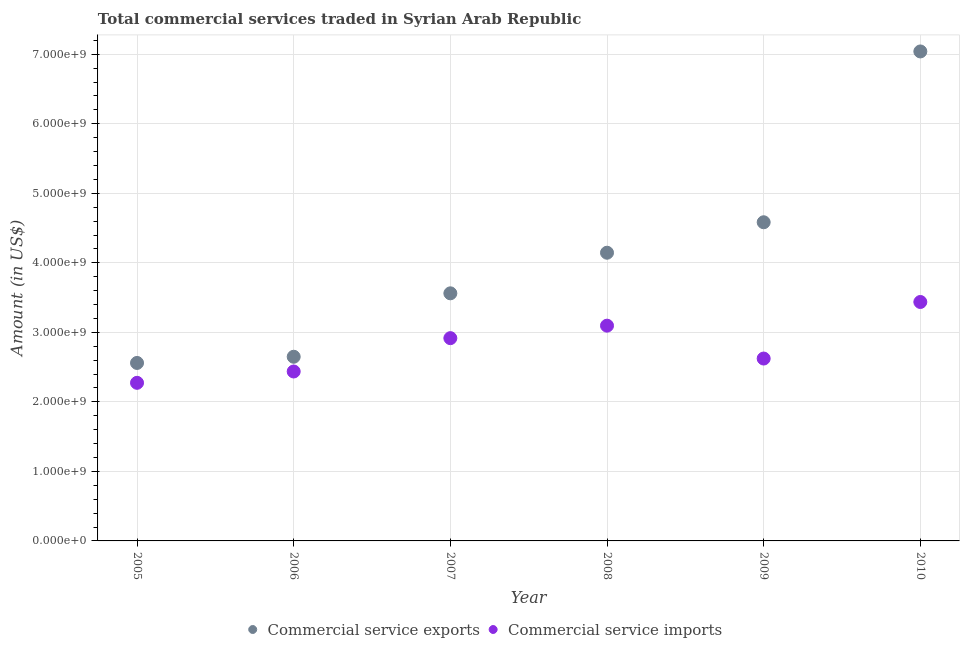Is the number of dotlines equal to the number of legend labels?
Ensure brevity in your answer.  Yes. What is the amount of commercial service imports in 2007?
Your answer should be compact. 2.92e+09. Across all years, what is the maximum amount of commercial service exports?
Your answer should be very brief. 7.04e+09. Across all years, what is the minimum amount of commercial service imports?
Provide a short and direct response. 2.27e+09. In which year was the amount of commercial service exports maximum?
Your answer should be very brief. 2010. What is the total amount of commercial service exports in the graph?
Your answer should be very brief. 2.45e+1. What is the difference between the amount of commercial service imports in 2005 and that in 2008?
Give a very brief answer. -8.22e+08. What is the difference between the amount of commercial service imports in 2010 and the amount of commercial service exports in 2005?
Offer a very short reply. 8.77e+08. What is the average amount of commercial service imports per year?
Give a very brief answer. 2.80e+09. In the year 2008, what is the difference between the amount of commercial service exports and amount of commercial service imports?
Your answer should be very brief. 1.05e+09. In how many years, is the amount of commercial service imports greater than 4800000000 US$?
Give a very brief answer. 0. What is the ratio of the amount of commercial service exports in 2007 to that in 2010?
Your answer should be very brief. 0.51. Is the difference between the amount of commercial service exports in 2008 and 2010 greater than the difference between the amount of commercial service imports in 2008 and 2010?
Keep it short and to the point. No. What is the difference between the highest and the second highest amount of commercial service exports?
Provide a succinct answer. 2.46e+09. What is the difference between the highest and the lowest amount of commercial service exports?
Provide a short and direct response. 4.48e+09. In how many years, is the amount of commercial service imports greater than the average amount of commercial service imports taken over all years?
Your response must be concise. 3. Does the amount of commercial service exports monotonically increase over the years?
Provide a succinct answer. Yes. Is the amount of commercial service imports strictly greater than the amount of commercial service exports over the years?
Offer a terse response. No. Is the amount of commercial service exports strictly less than the amount of commercial service imports over the years?
Ensure brevity in your answer.  No. Does the graph contain any zero values?
Provide a succinct answer. No. How are the legend labels stacked?
Your response must be concise. Horizontal. What is the title of the graph?
Your answer should be compact. Total commercial services traded in Syrian Arab Republic. Does "GDP per capita" appear as one of the legend labels in the graph?
Offer a very short reply. No. What is the Amount (in US$) in Commercial service exports in 2005?
Keep it short and to the point. 2.56e+09. What is the Amount (in US$) of Commercial service imports in 2005?
Your response must be concise. 2.27e+09. What is the Amount (in US$) in Commercial service exports in 2006?
Provide a succinct answer. 2.65e+09. What is the Amount (in US$) of Commercial service imports in 2006?
Ensure brevity in your answer.  2.44e+09. What is the Amount (in US$) in Commercial service exports in 2007?
Keep it short and to the point. 3.56e+09. What is the Amount (in US$) of Commercial service imports in 2007?
Offer a terse response. 2.92e+09. What is the Amount (in US$) in Commercial service exports in 2008?
Give a very brief answer. 4.15e+09. What is the Amount (in US$) of Commercial service imports in 2008?
Give a very brief answer. 3.10e+09. What is the Amount (in US$) in Commercial service exports in 2009?
Offer a very short reply. 4.58e+09. What is the Amount (in US$) in Commercial service imports in 2009?
Give a very brief answer. 2.62e+09. What is the Amount (in US$) in Commercial service exports in 2010?
Your response must be concise. 7.04e+09. What is the Amount (in US$) in Commercial service imports in 2010?
Your answer should be compact. 3.44e+09. Across all years, what is the maximum Amount (in US$) of Commercial service exports?
Give a very brief answer. 7.04e+09. Across all years, what is the maximum Amount (in US$) in Commercial service imports?
Offer a terse response. 3.44e+09. Across all years, what is the minimum Amount (in US$) of Commercial service exports?
Give a very brief answer. 2.56e+09. Across all years, what is the minimum Amount (in US$) in Commercial service imports?
Your answer should be very brief. 2.27e+09. What is the total Amount (in US$) in Commercial service exports in the graph?
Your answer should be very brief. 2.45e+1. What is the total Amount (in US$) in Commercial service imports in the graph?
Provide a succinct answer. 1.68e+1. What is the difference between the Amount (in US$) in Commercial service exports in 2005 and that in 2006?
Give a very brief answer. -8.90e+07. What is the difference between the Amount (in US$) in Commercial service imports in 2005 and that in 2006?
Your answer should be compact. -1.63e+08. What is the difference between the Amount (in US$) in Commercial service exports in 2005 and that in 2007?
Keep it short and to the point. -1.00e+09. What is the difference between the Amount (in US$) in Commercial service imports in 2005 and that in 2007?
Keep it short and to the point. -6.43e+08. What is the difference between the Amount (in US$) of Commercial service exports in 2005 and that in 2008?
Offer a terse response. -1.59e+09. What is the difference between the Amount (in US$) of Commercial service imports in 2005 and that in 2008?
Ensure brevity in your answer.  -8.22e+08. What is the difference between the Amount (in US$) in Commercial service exports in 2005 and that in 2009?
Ensure brevity in your answer.  -2.02e+09. What is the difference between the Amount (in US$) in Commercial service imports in 2005 and that in 2009?
Provide a succinct answer. -3.49e+08. What is the difference between the Amount (in US$) in Commercial service exports in 2005 and that in 2010?
Give a very brief answer. -4.48e+09. What is the difference between the Amount (in US$) of Commercial service imports in 2005 and that in 2010?
Give a very brief answer. -1.16e+09. What is the difference between the Amount (in US$) of Commercial service exports in 2006 and that in 2007?
Your answer should be very brief. -9.12e+08. What is the difference between the Amount (in US$) in Commercial service imports in 2006 and that in 2007?
Give a very brief answer. -4.80e+08. What is the difference between the Amount (in US$) of Commercial service exports in 2006 and that in 2008?
Your response must be concise. -1.50e+09. What is the difference between the Amount (in US$) in Commercial service imports in 2006 and that in 2008?
Your response must be concise. -6.59e+08. What is the difference between the Amount (in US$) of Commercial service exports in 2006 and that in 2009?
Offer a terse response. -1.93e+09. What is the difference between the Amount (in US$) of Commercial service imports in 2006 and that in 2009?
Your answer should be very brief. -1.86e+08. What is the difference between the Amount (in US$) in Commercial service exports in 2006 and that in 2010?
Your answer should be compact. -4.39e+09. What is the difference between the Amount (in US$) of Commercial service imports in 2006 and that in 2010?
Provide a short and direct response. -1.00e+09. What is the difference between the Amount (in US$) in Commercial service exports in 2007 and that in 2008?
Your answer should be compact. -5.84e+08. What is the difference between the Amount (in US$) of Commercial service imports in 2007 and that in 2008?
Ensure brevity in your answer.  -1.80e+08. What is the difference between the Amount (in US$) of Commercial service exports in 2007 and that in 2009?
Ensure brevity in your answer.  -1.02e+09. What is the difference between the Amount (in US$) of Commercial service imports in 2007 and that in 2009?
Give a very brief answer. 2.93e+08. What is the difference between the Amount (in US$) in Commercial service exports in 2007 and that in 2010?
Keep it short and to the point. -3.48e+09. What is the difference between the Amount (in US$) in Commercial service imports in 2007 and that in 2010?
Your answer should be very brief. -5.20e+08. What is the difference between the Amount (in US$) in Commercial service exports in 2008 and that in 2009?
Make the answer very short. -4.38e+08. What is the difference between the Amount (in US$) of Commercial service imports in 2008 and that in 2009?
Offer a terse response. 4.73e+08. What is the difference between the Amount (in US$) of Commercial service exports in 2008 and that in 2010?
Your answer should be very brief. -2.90e+09. What is the difference between the Amount (in US$) in Commercial service imports in 2008 and that in 2010?
Give a very brief answer. -3.41e+08. What is the difference between the Amount (in US$) of Commercial service exports in 2009 and that in 2010?
Offer a terse response. -2.46e+09. What is the difference between the Amount (in US$) in Commercial service imports in 2009 and that in 2010?
Provide a short and direct response. -8.14e+08. What is the difference between the Amount (in US$) of Commercial service exports in 2005 and the Amount (in US$) of Commercial service imports in 2006?
Ensure brevity in your answer.  1.23e+08. What is the difference between the Amount (in US$) of Commercial service exports in 2005 and the Amount (in US$) of Commercial service imports in 2007?
Offer a terse response. -3.57e+08. What is the difference between the Amount (in US$) in Commercial service exports in 2005 and the Amount (in US$) in Commercial service imports in 2008?
Give a very brief answer. -5.36e+08. What is the difference between the Amount (in US$) of Commercial service exports in 2005 and the Amount (in US$) of Commercial service imports in 2009?
Your answer should be very brief. -6.32e+07. What is the difference between the Amount (in US$) of Commercial service exports in 2005 and the Amount (in US$) of Commercial service imports in 2010?
Your response must be concise. -8.77e+08. What is the difference between the Amount (in US$) in Commercial service exports in 2006 and the Amount (in US$) in Commercial service imports in 2007?
Your answer should be very brief. -2.68e+08. What is the difference between the Amount (in US$) of Commercial service exports in 2006 and the Amount (in US$) of Commercial service imports in 2008?
Provide a short and direct response. -4.47e+08. What is the difference between the Amount (in US$) of Commercial service exports in 2006 and the Amount (in US$) of Commercial service imports in 2009?
Your answer should be very brief. 2.58e+07. What is the difference between the Amount (in US$) of Commercial service exports in 2006 and the Amount (in US$) of Commercial service imports in 2010?
Give a very brief answer. -7.88e+08. What is the difference between the Amount (in US$) in Commercial service exports in 2007 and the Amount (in US$) in Commercial service imports in 2008?
Offer a terse response. 4.65e+08. What is the difference between the Amount (in US$) of Commercial service exports in 2007 and the Amount (in US$) of Commercial service imports in 2009?
Provide a short and direct response. 9.38e+08. What is the difference between the Amount (in US$) in Commercial service exports in 2007 and the Amount (in US$) in Commercial service imports in 2010?
Your answer should be very brief. 1.25e+08. What is the difference between the Amount (in US$) in Commercial service exports in 2008 and the Amount (in US$) in Commercial service imports in 2009?
Keep it short and to the point. 1.52e+09. What is the difference between the Amount (in US$) in Commercial service exports in 2008 and the Amount (in US$) in Commercial service imports in 2010?
Your answer should be very brief. 7.09e+08. What is the difference between the Amount (in US$) of Commercial service exports in 2009 and the Amount (in US$) of Commercial service imports in 2010?
Provide a succinct answer. 1.15e+09. What is the average Amount (in US$) in Commercial service exports per year?
Offer a very short reply. 4.09e+09. What is the average Amount (in US$) of Commercial service imports per year?
Ensure brevity in your answer.  2.80e+09. In the year 2005, what is the difference between the Amount (in US$) of Commercial service exports and Amount (in US$) of Commercial service imports?
Provide a succinct answer. 2.86e+08. In the year 2006, what is the difference between the Amount (in US$) of Commercial service exports and Amount (in US$) of Commercial service imports?
Give a very brief answer. 2.12e+08. In the year 2007, what is the difference between the Amount (in US$) in Commercial service exports and Amount (in US$) in Commercial service imports?
Your answer should be very brief. 6.45e+08. In the year 2008, what is the difference between the Amount (in US$) in Commercial service exports and Amount (in US$) in Commercial service imports?
Your answer should be very brief. 1.05e+09. In the year 2009, what is the difference between the Amount (in US$) of Commercial service exports and Amount (in US$) of Commercial service imports?
Your answer should be very brief. 1.96e+09. In the year 2010, what is the difference between the Amount (in US$) in Commercial service exports and Amount (in US$) in Commercial service imports?
Provide a succinct answer. 3.60e+09. What is the ratio of the Amount (in US$) in Commercial service exports in 2005 to that in 2006?
Provide a succinct answer. 0.97. What is the ratio of the Amount (in US$) in Commercial service imports in 2005 to that in 2006?
Provide a short and direct response. 0.93. What is the ratio of the Amount (in US$) in Commercial service exports in 2005 to that in 2007?
Your answer should be compact. 0.72. What is the ratio of the Amount (in US$) of Commercial service imports in 2005 to that in 2007?
Give a very brief answer. 0.78. What is the ratio of the Amount (in US$) of Commercial service exports in 2005 to that in 2008?
Your answer should be very brief. 0.62. What is the ratio of the Amount (in US$) in Commercial service imports in 2005 to that in 2008?
Offer a very short reply. 0.73. What is the ratio of the Amount (in US$) of Commercial service exports in 2005 to that in 2009?
Offer a very short reply. 0.56. What is the ratio of the Amount (in US$) in Commercial service imports in 2005 to that in 2009?
Your answer should be compact. 0.87. What is the ratio of the Amount (in US$) in Commercial service exports in 2005 to that in 2010?
Ensure brevity in your answer.  0.36. What is the ratio of the Amount (in US$) of Commercial service imports in 2005 to that in 2010?
Provide a short and direct response. 0.66. What is the ratio of the Amount (in US$) in Commercial service exports in 2006 to that in 2007?
Provide a short and direct response. 0.74. What is the ratio of the Amount (in US$) of Commercial service imports in 2006 to that in 2007?
Make the answer very short. 0.84. What is the ratio of the Amount (in US$) in Commercial service exports in 2006 to that in 2008?
Your response must be concise. 0.64. What is the ratio of the Amount (in US$) of Commercial service imports in 2006 to that in 2008?
Your answer should be compact. 0.79. What is the ratio of the Amount (in US$) of Commercial service exports in 2006 to that in 2009?
Offer a terse response. 0.58. What is the ratio of the Amount (in US$) in Commercial service imports in 2006 to that in 2009?
Your answer should be very brief. 0.93. What is the ratio of the Amount (in US$) of Commercial service exports in 2006 to that in 2010?
Provide a succinct answer. 0.38. What is the ratio of the Amount (in US$) of Commercial service imports in 2006 to that in 2010?
Provide a succinct answer. 0.71. What is the ratio of the Amount (in US$) in Commercial service exports in 2007 to that in 2008?
Provide a succinct answer. 0.86. What is the ratio of the Amount (in US$) of Commercial service imports in 2007 to that in 2008?
Make the answer very short. 0.94. What is the ratio of the Amount (in US$) in Commercial service exports in 2007 to that in 2009?
Your answer should be very brief. 0.78. What is the ratio of the Amount (in US$) in Commercial service imports in 2007 to that in 2009?
Your answer should be very brief. 1.11. What is the ratio of the Amount (in US$) of Commercial service exports in 2007 to that in 2010?
Your answer should be compact. 0.51. What is the ratio of the Amount (in US$) of Commercial service imports in 2007 to that in 2010?
Provide a short and direct response. 0.85. What is the ratio of the Amount (in US$) of Commercial service exports in 2008 to that in 2009?
Keep it short and to the point. 0.9. What is the ratio of the Amount (in US$) in Commercial service imports in 2008 to that in 2009?
Make the answer very short. 1.18. What is the ratio of the Amount (in US$) of Commercial service exports in 2008 to that in 2010?
Your answer should be very brief. 0.59. What is the ratio of the Amount (in US$) of Commercial service imports in 2008 to that in 2010?
Offer a terse response. 0.9. What is the ratio of the Amount (in US$) in Commercial service exports in 2009 to that in 2010?
Keep it short and to the point. 0.65. What is the ratio of the Amount (in US$) of Commercial service imports in 2009 to that in 2010?
Provide a short and direct response. 0.76. What is the difference between the highest and the second highest Amount (in US$) of Commercial service exports?
Your answer should be very brief. 2.46e+09. What is the difference between the highest and the second highest Amount (in US$) of Commercial service imports?
Keep it short and to the point. 3.41e+08. What is the difference between the highest and the lowest Amount (in US$) in Commercial service exports?
Your answer should be compact. 4.48e+09. What is the difference between the highest and the lowest Amount (in US$) of Commercial service imports?
Keep it short and to the point. 1.16e+09. 